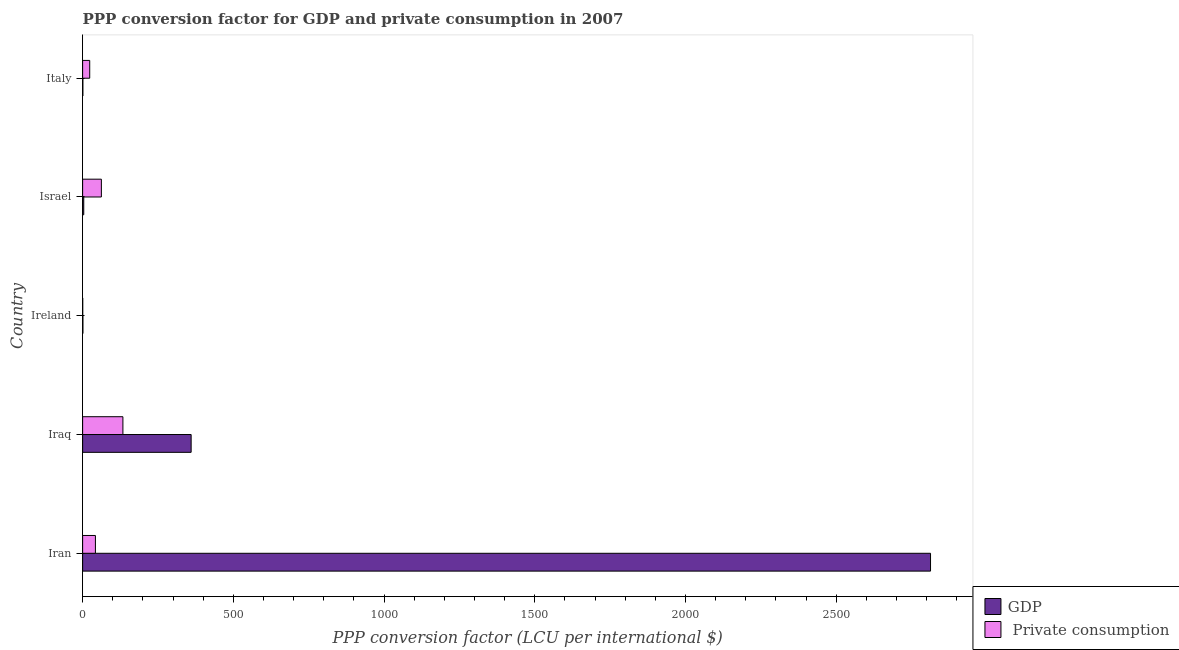Are the number of bars per tick equal to the number of legend labels?
Ensure brevity in your answer.  Yes. What is the label of the 3rd group of bars from the top?
Make the answer very short. Ireland. What is the ppp conversion factor for private consumption in Ireland?
Ensure brevity in your answer.  0.28. Across all countries, what is the maximum ppp conversion factor for gdp?
Provide a succinct answer. 2812.69. Across all countries, what is the minimum ppp conversion factor for gdp?
Offer a very short reply. 0.82. In which country was the ppp conversion factor for private consumption maximum?
Offer a very short reply. Iraq. In which country was the ppp conversion factor for gdp minimum?
Offer a terse response. Italy. What is the total ppp conversion factor for gdp in the graph?
Offer a terse response. 3178.16. What is the difference between the ppp conversion factor for private consumption in Iraq and that in Israel?
Your response must be concise. 71.41. What is the difference between the ppp conversion factor for private consumption in Italy and the ppp conversion factor for gdp in Iraq?
Your answer should be compact. -336.46. What is the average ppp conversion factor for gdp per country?
Offer a terse response. 635.63. What is the difference between the ppp conversion factor for gdp and ppp conversion factor for private consumption in Iran?
Your response must be concise. 2770.24. What is the ratio of the ppp conversion factor for gdp in Iraq to that in Israel?
Make the answer very short. 96.86. Is the ppp conversion factor for private consumption in Ireland less than that in Israel?
Your answer should be compact. Yes. Is the difference between the ppp conversion factor for private consumption in Iran and Israel greater than the difference between the ppp conversion factor for gdp in Iran and Israel?
Your response must be concise. No. What is the difference between the highest and the second highest ppp conversion factor for private consumption?
Your response must be concise. 71.41. What is the difference between the highest and the lowest ppp conversion factor for private consumption?
Provide a succinct answer. 133.3. In how many countries, is the ppp conversion factor for gdp greater than the average ppp conversion factor for gdp taken over all countries?
Provide a short and direct response. 1. What does the 2nd bar from the top in Iraq represents?
Offer a very short reply. GDP. What does the 2nd bar from the bottom in Iran represents?
Your answer should be very brief.  Private consumption. How many bars are there?
Offer a very short reply. 10. Are all the bars in the graph horizontal?
Keep it short and to the point. Yes. Does the graph contain any zero values?
Offer a very short reply. No. Where does the legend appear in the graph?
Your response must be concise. Bottom right. How many legend labels are there?
Your response must be concise. 2. What is the title of the graph?
Make the answer very short. PPP conversion factor for GDP and private consumption in 2007. What is the label or title of the X-axis?
Make the answer very short. PPP conversion factor (LCU per international $). What is the PPP conversion factor (LCU per international $) in GDP in Iran?
Give a very brief answer. 2812.69. What is the PPP conversion factor (LCU per international $) in  Private consumption in Iran?
Keep it short and to the point. 42.45. What is the PPP conversion factor (LCU per international $) in GDP in Iraq?
Your answer should be very brief. 359.97. What is the PPP conversion factor (LCU per international $) in  Private consumption in Iraq?
Your response must be concise. 133.58. What is the PPP conversion factor (LCU per international $) in GDP in Ireland?
Ensure brevity in your answer.  0.96. What is the PPP conversion factor (LCU per international $) in  Private consumption in Ireland?
Keep it short and to the point. 0.28. What is the PPP conversion factor (LCU per international $) of GDP in Israel?
Make the answer very short. 3.72. What is the PPP conversion factor (LCU per international $) in  Private consumption in Israel?
Ensure brevity in your answer.  62.17. What is the PPP conversion factor (LCU per international $) of GDP in Italy?
Give a very brief answer. 0.82. What is the PPP conversion factor (LCU per international $) in  Private consumption in Italy?
Provide a short and direct response. 23.51. Across all countries, what is the maximum PPP conversion factor (LCU per international $) of GDP?
Your answer should be compact. 2812.69. Across all countries, what is the maximum PPP conversion factor (LCU per international $) of  Private consumption?
Give a very brief answer. 133.58. Across all countries, what is the minimum PPP conversion factor (LCU per international $) of GDP?
Your response must be concise. 0.82. Across all countries, what is the minimum PPP conversion factor (LCU per international $) of  Private consumption?
Offer a very short reply. 0.28. What is the total PPP conversion factor (LCU per international $) in GDP in the graph?
Ensure brevity in your answer.  3178.16. What is the total PPP conversion factor (LCU per international $) in  Private consumption in the graph?
Provide a succinct answer. 262. What is the difference between the PPP conversion factor (LCU per international $) of GDP in Iran and that in Iraq?
Keep it short and to the point. 2452.72. What is the difference between the PPP conversion factor (LCU per international $) in  Private consumption in Iran and that in Iraq?
Your response must be concise. -91.13. What is the difference between the PPP conversion factor (LCU per international $) in GDP in Iran and that in Ireland?
Provide a short and direct response. 2811.73. What is the difference between the PPP conversion factor (LCU per international $) in  Private consumption in Iran and that in Ireland?
Give a very brief answer. 42.18. What is the difference between the PPP conversion factor (LCU per international $) of GDP in Iran and that in Israel?
Offer a terse response. 2808.98. What is the difference between the PPP conversion factor (LCU per international $) in  Private consumption in Iran and that in Israel?
Offer a very short reply. -19.72. What is the difference between the PPP conversion factor (LCU per international $) in GDP in Iran and that in Italy?
Provide a short and direct response. 2811.88. What is the difference between the PPP conversion factor (LCU per international $) in  Private consumption in Iran and that in Italy?
Your answer should be compact. 18.94. What is the difference between the PPP conversion factor (LCU per international $) in GDP in Iraq and that in Ireland?
Make the answer very short. 359.01. What is the difference between the PPP conversion factor (LCU per international $) of  Private consumption in Iraq and that in Ireland?
Provide a succinct answer. 133.3. What is the difference between the PPP conversion factor (LCU per international $) of GDP in Iraq and that in Israel?
Offer a very short reply. 356.26. What is the difference between the PPP conversion factor (LCU per international $) of  Private consumption in Iraq and that in Israel?
Your answer should be compact. 71.41. What is the difference between the PPP conversion factor (LCU per international $) in GDP in Iraq and that in Italy?
Offer a very short reply. 359.16. What is the difference between the PPP conversion factor (LCU per international $) of  Private consumption in Iraq and that in Italy?
Give a very brief answer. 110.07. What is the difference between the PPP conversion factor (LCU per international $) of GDP in Ireland and that in Israel?
Offer a very short reply. -2.76. What is the difference between the PPP conversion factor (LCU per international $) of  Private consumption in Ireland and that in Israel?
Your response must be concise. -61.89. What is the difference between the PPP conversion factor (LCU per international $) in GDP in Ireland and that in Italy?
Your answer should be compact. 0.14. What is the difference between the PPP conversion factor (LCU per international $) of  Private consumption in Ireland and that in Italy?
Your answer should be very brief. -23.24. What is the difference between the PPP conversion factor (LCU per international $) in GDP in Israel and that in Italy?
Your answer should be very brief. 2.9. What is the difference between the PPP conversion factor (LCU per international $) in  Private consumption in Israel and that in Italy?
Offer a terse response. 38.66. What is the difference between the PPP conversion factor (LCU per international $) in GDP in Iran and the PPP conversion factor (LCU per international $) in  Private consumption in Iraq?
Keep it short and to the point. 2679.11. What is the difference between the PPP conversion factor (LCU per international $) in GDP in Iran and the PPP conversion factor (LCU per international $) in  Private consumption in Ireland?
Give a very brief answer. 2812.42. What is the difference between the PPP conversion factor (LCU per international $) of GDP in Iran and the PPP conversion factor (LCU per international $) of  Private consumption in Israel?
Offer a terse response. 2750.52. What is the difference between the PPP conversion factor (LCU per international $) of GDP in Iran and the PPP conversion factor (LCU per international $) of  Private consumption in Italy?
Your answer should be very brief. 2789.18. What is the difference between the PPP conversion factor (LCU per international $) in GDP in Iraq and the PPP conversion factor (LCU per international $) in  Private consumption in Ireland?
Offer a very short reply. 359.7. What is the difference between the PPP conversion factor (LCU per international $) in GDP in Iraq and the PPP conversion factor (LCU per international $) in  Private consumption in Israel?
Offer a terse response. 297.8. What is the difference between the PPP conversion factor (LCU per international $) of GDP in Iraq and the PPP conversion factor (LCU per international $) of  Private consumption in Italy?
Ensure brevity in your answer.  336.46. What is the difference between the PPP conversion factor (LCU per international $) in GDP in Ireland and the PPP conversion factor (LCU per international $) in  Private consumption in Israel?
Ensure brevity in your answer.  -61.21. What is the difference between the PPP conversion factor (LCU per international $) in GDP in Ireland and the PPP conversion factor (LCU per international $) in  Private consumption in Italy?
Provide a short and direct response. -22.56. What is the difference between the PPP conversion factor (LCU per international $) in GDP in Israel and the PPP conversion factor (LCU per international $) in  Private consumption in Italy?
Offer a terse response. -19.8. What is the average PPP conversion factor (LCU per international $) in GDP per country?
Offer a very short reply. 635.63. What is the average PPP conversion factor (LCU per international $) in  Private consumption per country?
Offer a very short reply. 52.4. What is the difference between the PPP conversion factor (LCU per international $) of GDP and PPP conversion factor (LCU per international $) of  Private consumption in Iran?
Give a very brief answer. 2770.24. What is the difference between the PPP conversion factor (LCU per international $) of GDP and PPP conversion factor (LCU per international $) of  Private consumption in Iraq?
Your response must be concise. 226.39. What is the difference between the PPP conversion factor (LCU per international $) of GDP and PPP conversion factor (LCU per international $) of  Private consumption in Ireland?
Provide a short and direct response. 0.68. What is the difference between the PPP conversion factor (LCU per international $) of GDP and PPP conversion factor (LCU per international $) of  Private consumption in Israel?
Provide a succinct answer. -58.46. What is the difference between the PPP conversion factor (LCU per international $) in GDP and PPP conversion factor (LCU per international $) in  Private consumption in Italy?
Provide a short and direct response. -22.7. What is the ratio of the PPP conversion factor (LCU per international $) in GDP in Iran to that in Iraq?
Provide a short and direct response. 7.81. What is the ratio of the PPP conversion factor (LCU per international $) of  Private consumption in Iran to that in Iraq?
Make the answer very short. 0.32. What is the ratio of the PPP conversion factor (LCU per international $) in GDP in Iran to that in Ireland?
Give a very brief answer. 2934.8. What is the ratio of the PPP conversion factor (LCU per international $) of  Private consumption in Iran to that in Ireland?
Make the answer very short. 153.37. What is the ratio of the PPP conversion factor (LCU per international $) in GDP in Iran to that in Israel?
Provide a succinct answer. 756.86. What is the ratio of the PPP conversion factor (LCU per international $) in  Private consumption in Iran to that in Israel?
Your answer should be compact. 0.68. What is the ratio of the PPP conversion factor (LCU per international $) in GDP in Iran to that in Italy?
Offer a terse response. 3443.05. What is the ratio of the PPP conversion factor (LCU per international $) of  Private consumption in Iran to that in Italy?
Your answer should be compact. 1.81. What is the ratio of the PPP conversion factor (LCU per international $) of GDP in Iraq to that in Ireland?
Make the answer very short. 375.6. What is the ratio of the PPP conversion factor (LCU per international $) of  Private consumption in Iraq to that in Ireland?
Offer a terse response. 482.59. What is the ratio of the PPP conversion factor (LCU per international $) in GDP in Iraq to that in Israel?
Your answer should be compact. 96.86. What is the ratio of the PPP conversion factor (LCU per international $) of  Private consumption in Iraq to that in Israel?
Offer a very short reply. 2.15. What is the ratio of the PPP conversion factor (LCU per international $) in GDP in Iraq to that in Italy?
Your answer should be compact. 440.65. What is the ratio of the PPP conversion factor (LCU per international $) of  Private consumption in Iraq to that in Italy?
Provide a short and direct response. 5.68. What is the ratio of the PPP conversion factor (LCU per international $) in GDP in Ireland to that in Israel?
Make the answer very short. 0.26. What is the ratio of the PPP conversion factor (LCU per international $) of  Private consumption in Ireland to that in Israel?
Give a very brief answer. 0. What is the ratio of the PPP conversion factor (LCU per international $) in GDP in Ireland to that in Italy?
Ensure brevity in your answer.  1.17. What is the ratio of the PPP conversion factor (LCU per international $) in  Private consumption in Ireland to that in Italy?
Provide a short and direct response. 0.01. What is the ratio of the PPP conversion factor (LCU per international $) in GDP in Israel to that in Italy?
Give a very brief answer. 4.55. What is the ratio of the PPP conversion factor (LCU per international $) of  Private consumption in Israel to that in Italy?
Make the answer very short. 2.64. What is the difference between the highest and the second highest PPP conversion factor (LCU per international $) in GDP?
Keep it short and to the point. 2452.72. What is the difference between the highest and the second highest PPP conversion factor (LCU per international $) of  Private consumption?
Offer a very short reply. 71.41. What is the difference between the highest and the lowest PPP conversion factor (LCU per international $) of GDP?
Keep it short and to the point. 2811.88. What is the difference between the highest and the lowest PPP conversion factor (LCU per international $) of  Private consumption?
Your answer should be compact. 133.3. 